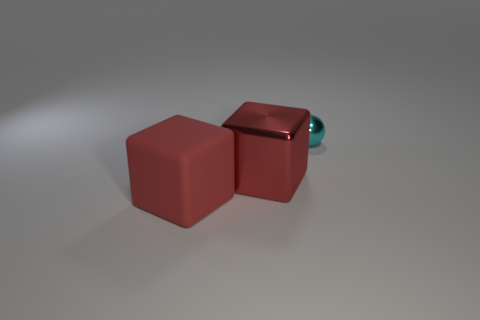Is the number of big blue balls less than the number of cyan shiny balls? Actually, in the image, there are no big blue balls nor cyan shiny balls. Instead, there are two red cubes and a small shiny sphere of a teal or turquoise color. 